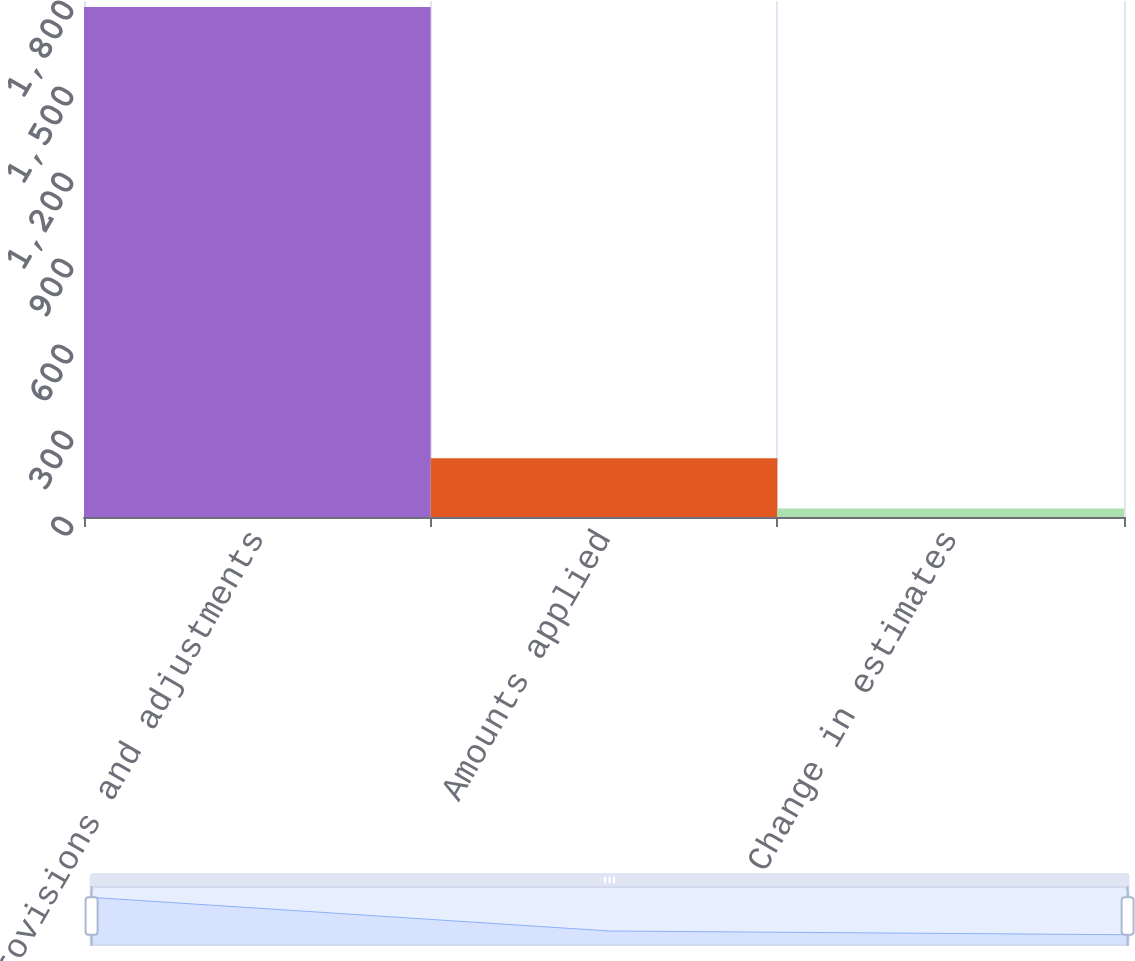<chart> <loc_0><loc_0><loc_500><loc_500><bar_chart><fcel>Provisions and adjustments<fcel>Amounts applied<fcel>Change in estimates<nl><fcel>1779<fcel>204.9<fcel>30<nl></chart> 